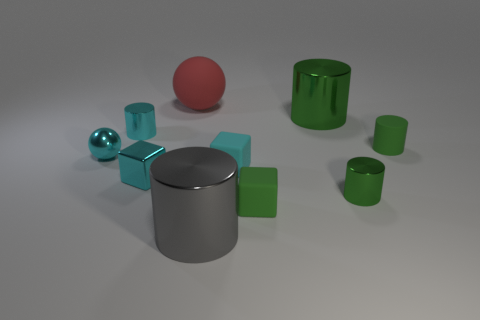Does the tiny shiny ball have the same color as the cylinder left of the big gray metallic object?
Ensure brevity in your answer.  Yes. Is the number of small cylinders that are behind the green rubber cylinder the same as the number of small metallic objects that are to the right of the gray metallic object?
Your response must be concise. Yes. What number of other objects are there of the same size as the gray metallic object?
Offer a very short reply. 2. The red matte sphere is what size?
Offer a very short reply. Large. Does the big red object have the same material as the small cyan thing that is to the right of the big red ball?
Provide a short and direct response. Yes. Is there a gray thing of the same shape as the tiny green metallic object?
Your answer should be compact. Yes. There is a sphere that is the same size as the gray metal cylinder; what material is it?
Offer a terse response. Rubber. There is a green metallic cylinder behind the small green rubber cylinder; what size is it?
Keep it short and to the point. Large. There is a cyan shiny cube that is left of the big red ball; is its size the same as the gray shiny object in front of the small ball?
Make the answer very short. No. How many large balls have the same material as the small green block?
Give a very brief answer. 1. 